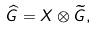Convert formula to latex. <formula><loc_0><loc_0><loc_500><loc_500>\widehat { G } = X \otimes \widetilde { G } ,</formula> 